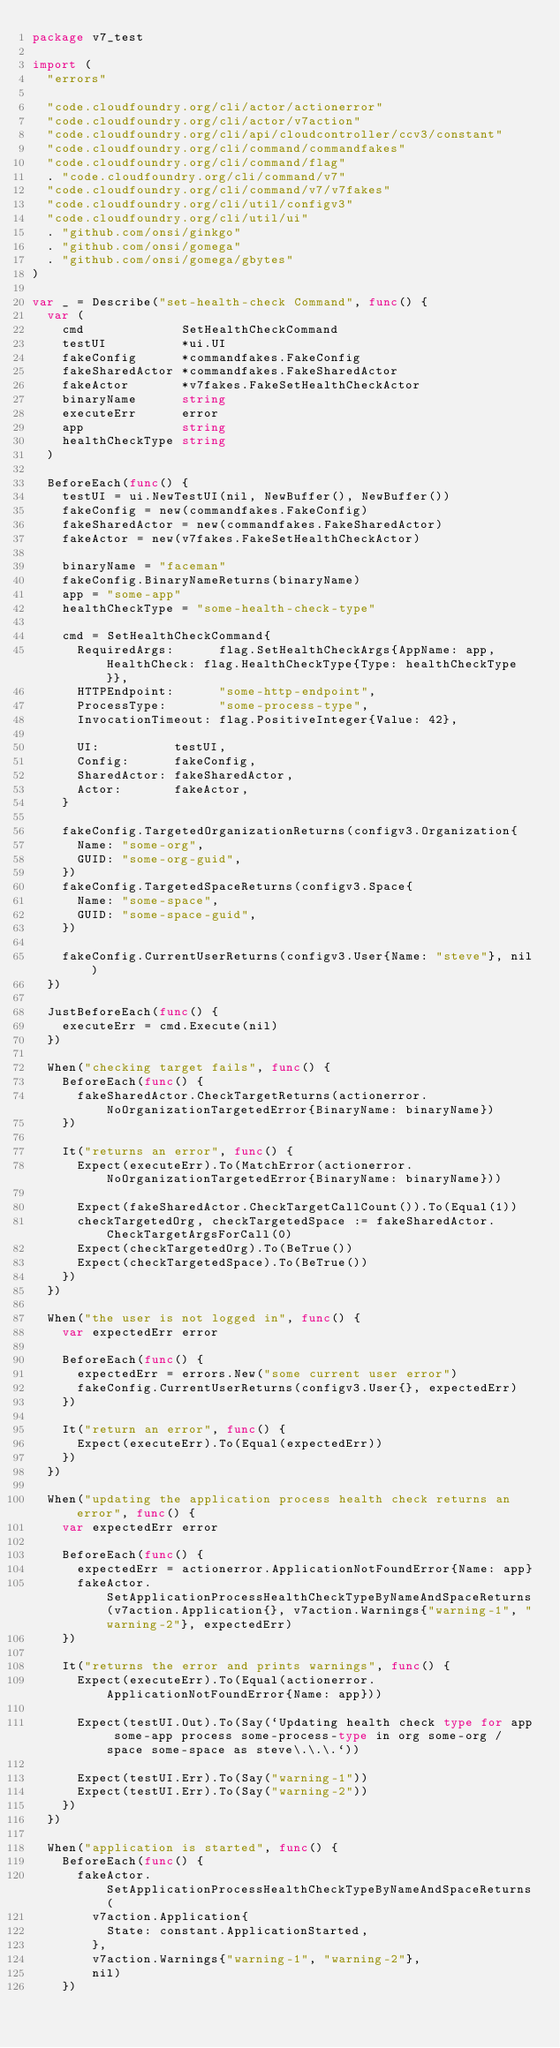<code> <loc_0><loc_0><loc_500><loc_500><_Go_>package v7_test

import (
	"errors"

	"code.cloudfoundry.org/cli/actor/actionerror"
	"code.cloudfoundry.org/cli/actor/v7action"
	"code.cloudfoundry.org/cli/api/cloudcontroller/ccv3/constant"
	"code.cloudfoundry.org/cli/command/commandfakes"
	"code.cloudfoundry.org/cli/command/flag"
	. "code.cloudfoundry.org/cli/command/v7"
	"code.cloudfoundry.org/cli/command/v7/v7fakes"
	"code.cloudfoundry.org/cli/util/configv3"
	"code.cloudfoundry.org/cli/util/ui"
	. "github.com/onsi/ginkgo"
	. "github.com/onsi/gomega"
	. "github.com/onsi/gomega/gbytes"
)

var _ = Describe("set-health-check Command", func() {
	var (
		cmd             SetHealthCheckCommand
		testUI          *ui.UI
		fakeConfig      *commandfakes.FakeConfig
		fakeSharedActor *commandfakes.FakeSharedActor
		fakeActor       *v7fakes.FakeSetHealthCheckActor
		binaryName      string
		executeErr      error
		app             string
		healthCheckType string
	)

	BeforeEach(func() {
		testUI = ui.NewTestUI(nil, NewBuffer(), NewBuffer())
		fakeConfig = new(commandfakes.FakeConfig)
		fakeSharedActor = new(commandfakes.FakeSharedActor)
		fakeActor = new(v7fakes.FakeSetHealthCheckActor)

		binaryName = "faceman"
		fakeConfig.BinaryNameReturns(binaryName)
		app = "some-app"
		healthCheckType = "some-health-check-type"

		cmd = SetHealthCheckCommand{
			RequiredArgs:      flag.SetHealthCheckArgs{AppName: app, HealthCheck: flag.HealthCheckType{Type: healthCheckType}},
			HTTPEndpoint:      "some-http-endpoint",
			ProcessType:       "some-process-type",
			InvocationTimeout: flag.PositiveInteger{Value: 42},

			UI:          testUI,
			Config:      fakeConfig,
			SharedActor: fakeSharedActor,
			Actor:       fakeActor,
		}

		fakeConfig.TargetedOrganizationReturns(configv3.Organization{
			Name: "some-org",
			GUID: "some-org-guid",
		})
		fakeConfig.TargetedSpaceReturns(configv3.Space{
			Name: "some-space",
			GUID: "some-space-guid",
		})

		fakeConfig.CurrentUserReturns(configv3.User{Name: "steve"}, nil)
	})

	JustBeforeEach(func() {
		executeErr = cmd.Execute(nil)
	})

	When("checking target fails", func() {
		BeforeEach(func() {
			fakeSharedActor.CheckTargetReturns(actionerror.NoOrganizationTargetedError{BinaryName: binaryName})
		})

		It("returns an error", func() {
			Expect(executeErr).To(MatchError(actionerror.NoOrganizationTargetedError{BinaryName: binaryName}))

			Expect(fakeSharedActor.CheckTargetCallCount()).To(Equal(1))
			checkTargetedOrg, checkTargetedSpace := fakeSharedActor.CheckTargetArgsForCall(0)
			Expect(checkTargetedOrg).To(BeTrue())
			Expect(checkTargetedSpace).To(BeTrue())
		})
	})

	When("the user is not logged in", func() {
		var expectedErr error

		BeforeEach(func() {
			expectedErr = errors.New("some current user error")
			fakeConfig.CurrentUserReturns(configv3.User{}, expectedErr)
		})

		It("return an error", func() {
			Expect(executeErr).To(Equal(expectedErr))
		})
	})

	When("updating the application process health check returns an error", func() {
		var expectedErr error

		BeforeEach(func() {
			expectedErr = actionerror.ApplicationNotFoundError{Name: app}
			fakeActor.SetApplicationProcessHealthCheckTypeByNameAndSpaceReturns(v7action.Application{}, v7action.Warnings{"warning-1", "warning-2"}, expectedErr)
		})

		It("returns the error and prints warnings", func() {
			Expect(executeErr).To(Equal(actionerror.ApplicationNotFoundError{Name: app}))

			Expect(testUI.Out).To(Say(`Updating health check type for app some-app process some-process-type in org some-org / space some-space as steve\.\.\.`))

			Expect(testUI.Err).To(Say("warning-1"))
			Expect(testUI.Err).To(Say("warning-2"))
		})
	})

	When("application is started", func() {
		BeforeEach(func() {
			fakeActor.SetApplicationProcessHealthCheckTypeByNameAndSpaceReturns(
				v7action.Application{
					State: constant.ApplicationStarted,
				},
				v7action.Warnings{"warning-1", "warning-2"},
				nil)
		})
</code> 